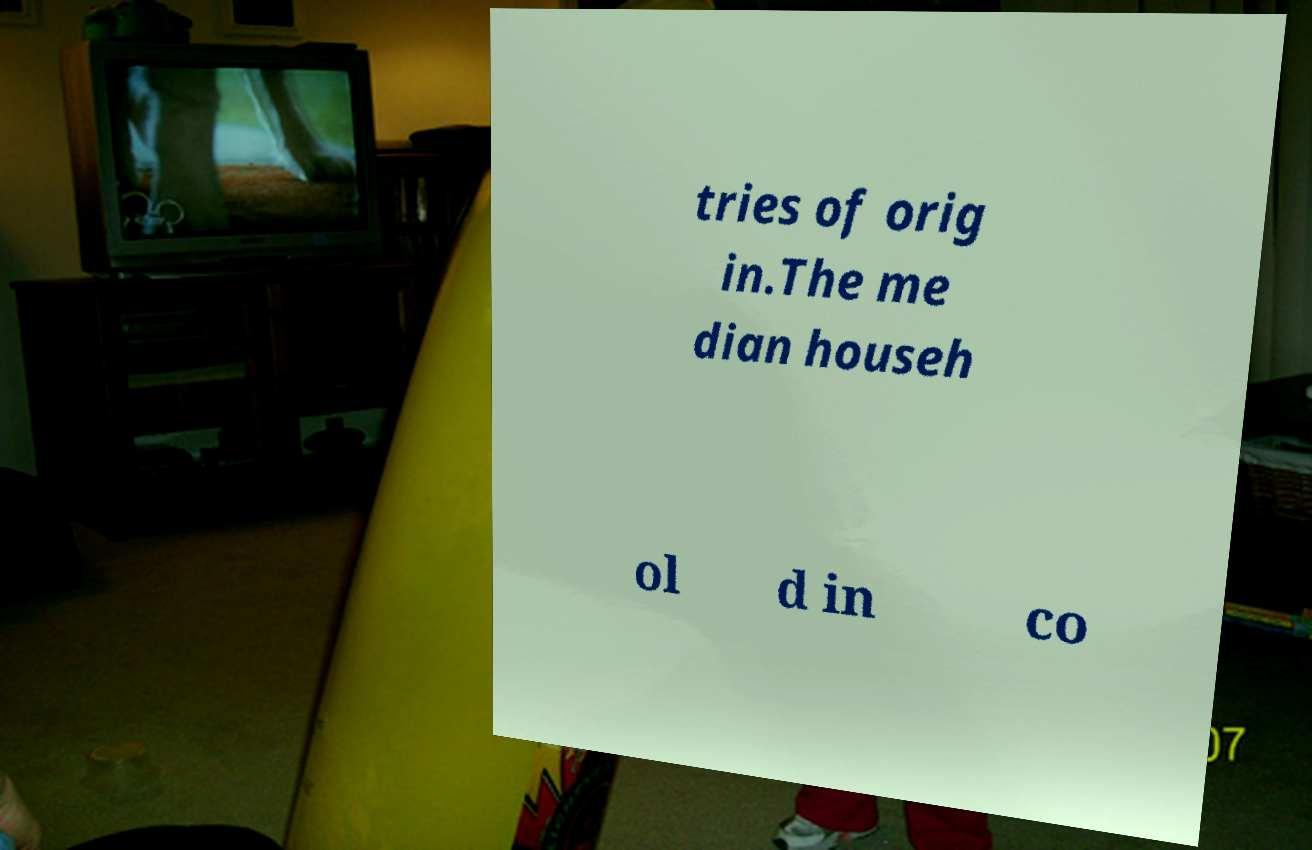Can you accurately transcribe the text from the provided image for me? tries of orig in.The me dian househ ol d in co 